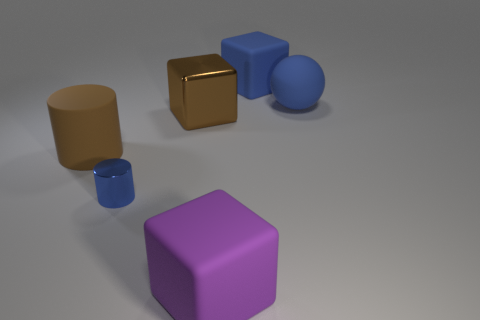There is a tiny metallic thing; is its shape the same as the big rubber object that is on the left side of the tiny blue cylinder? Yes, the tiny metallic object has a cube shape which is identical to the large rubber object to the left of the small blue cylinder. Both share the geometric property of having six faces, twelve edges, and eight vertices, each angle being a right angle and the faces being square. 